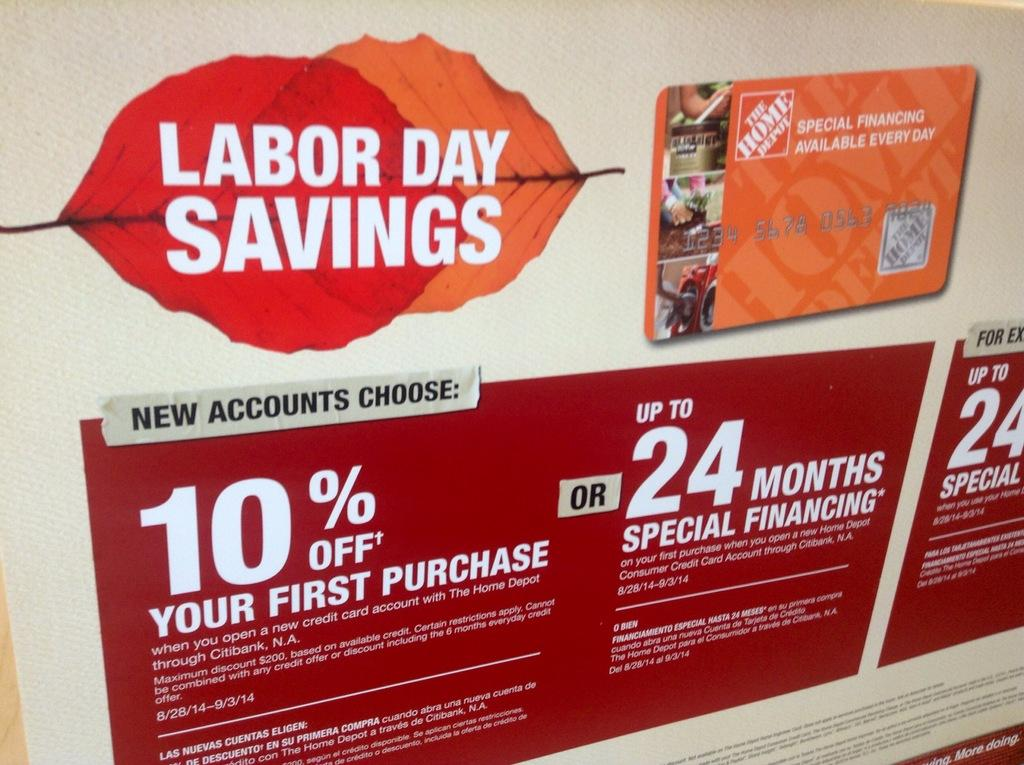What is the main object in the picture? There is a hoarding board in the picture. What is written or displayed on the hoarding board? There is text on the hoarding board. How is the text presented on the hoarding board? The text is on leaves. What else can be seen on the hoarding board? There is an electronic access card on the right side of the hoarding board. How many dolls are sitting on the rock in the image? There are no dolls or rocks present in the image; it features a hoarding board with text on leaves and an electronic access card. 